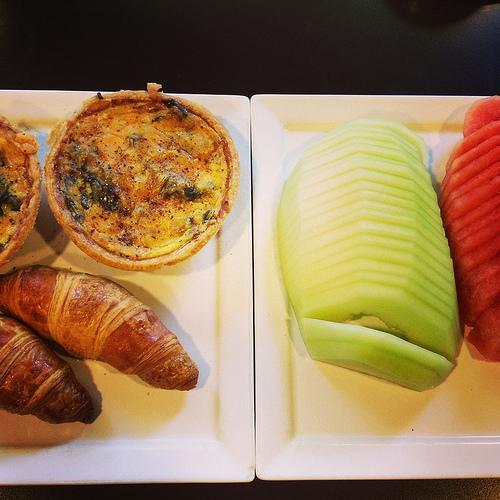How many plates are there?
Give a very brief answer. 2. 